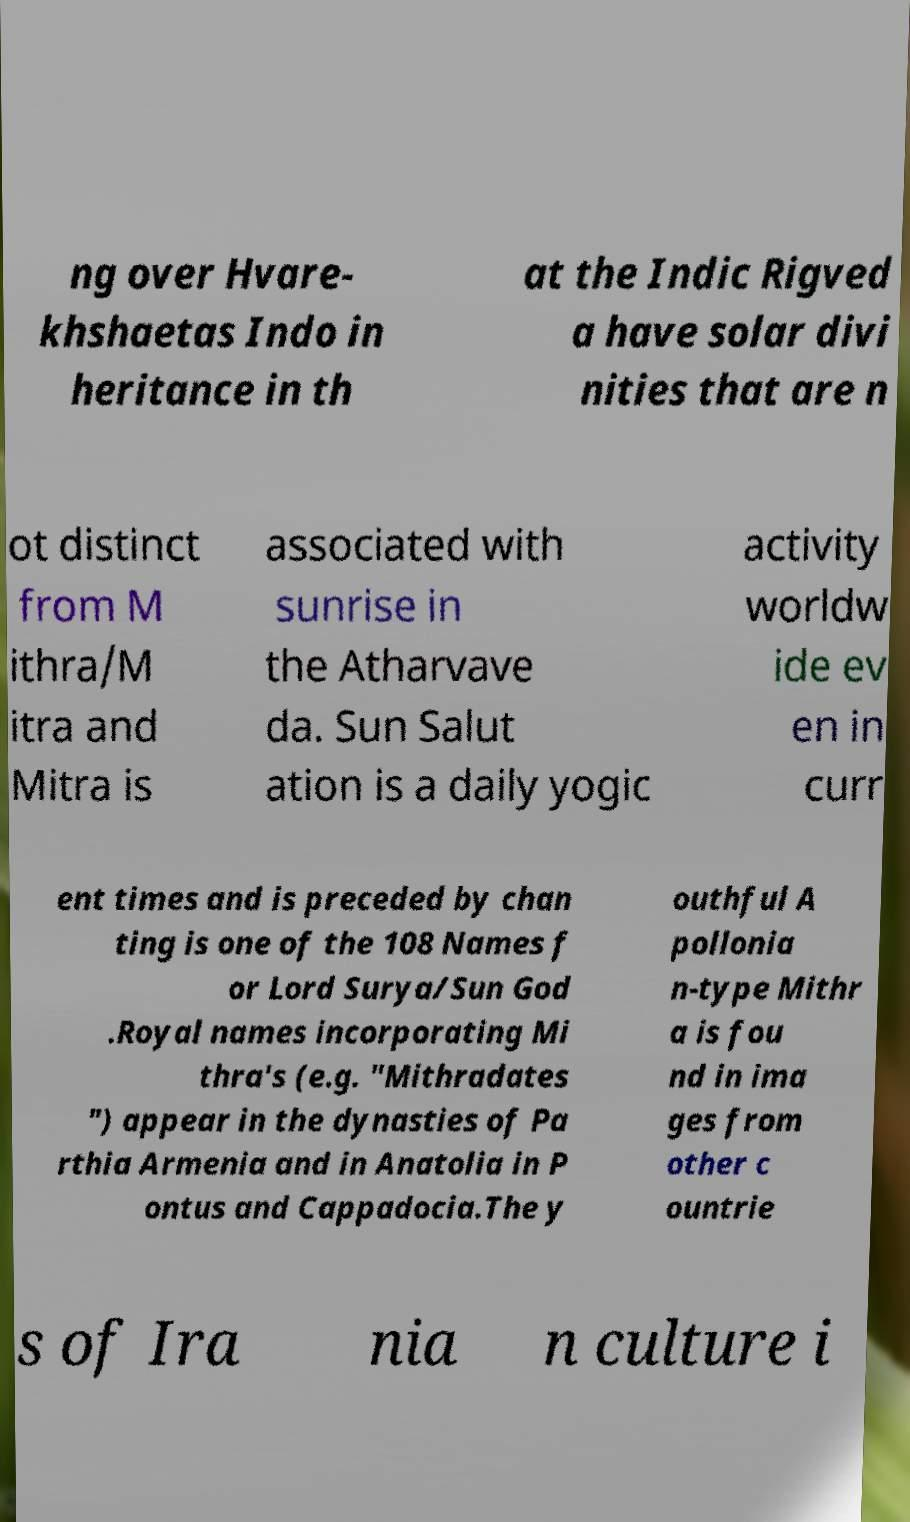Can you read and provide the text displayed in the image?This photo seems to have some interesting text. Can you extract and type it out for me? ng over Hvare- khshaetas Indo in heritance in th at the Indic Rigved a have solar divi nities that are n ot distinct from M ithra/M itra and Mitra is associated with sunrise in the Atharvave da. Sun Salut ation is a daily yogic activity worldw ide ev en in curr ent times and is preceded by chan ting is one of the 108 Names f or Lord Surya/Sun God .Royal names incorporating Mi thra's (e.g. "Mithradates ") appear in the dynasties of Pa rthia Armenia and in Anatolia in P ontus and Cappadocia.The y outhful A pollonia n-type Mithr a is fou nd in ima ges from other c ountrie s of Ira nia n culture i 